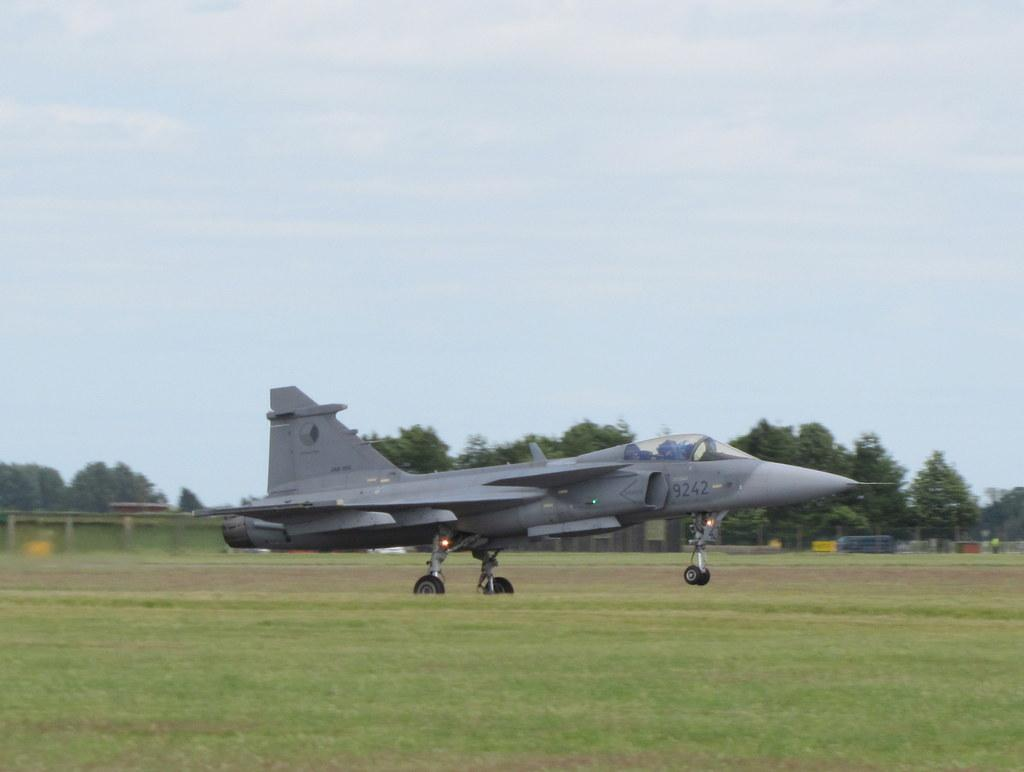What is the main subject of the picture? The main subject of the picture is a plane. What is the plane doing in the picture? The plane is taking off from the ground surface. What can be seen in the background of the picture? There are many trees behind the plane. What type of milk can be seen being poured into the plane's fuel tank in the image? There is no milk or fuel tank present in the image; it features a plane taking off from the ground surface with trees in the background. 